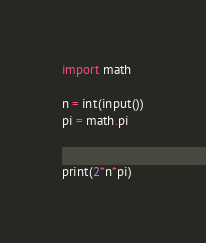<code> <loc_0><loc_0><loc_500><loc_500><_Python_>import math

n = int(input())
pi = math.pi


print(2*n*pi)</code> 